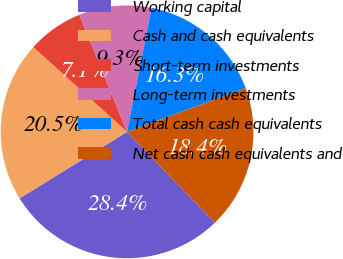Convert chart to OTSL. <chart><loc_0><loc_0><loc_500><loc_500><pie_chart><fcel>Working capital<fcel>Cash and cash equivalents<fcel>Short-term investments<fcel>Long-term investments<fcel>Total cash cash equivalents<fcel>Net cash cash equivalents and<nl><fcel>28.4%<fcel>20.52%<fcel>7.14%<fcel>9.27%<fcel>16.27%<fcel>18.39%<nl></chart> 